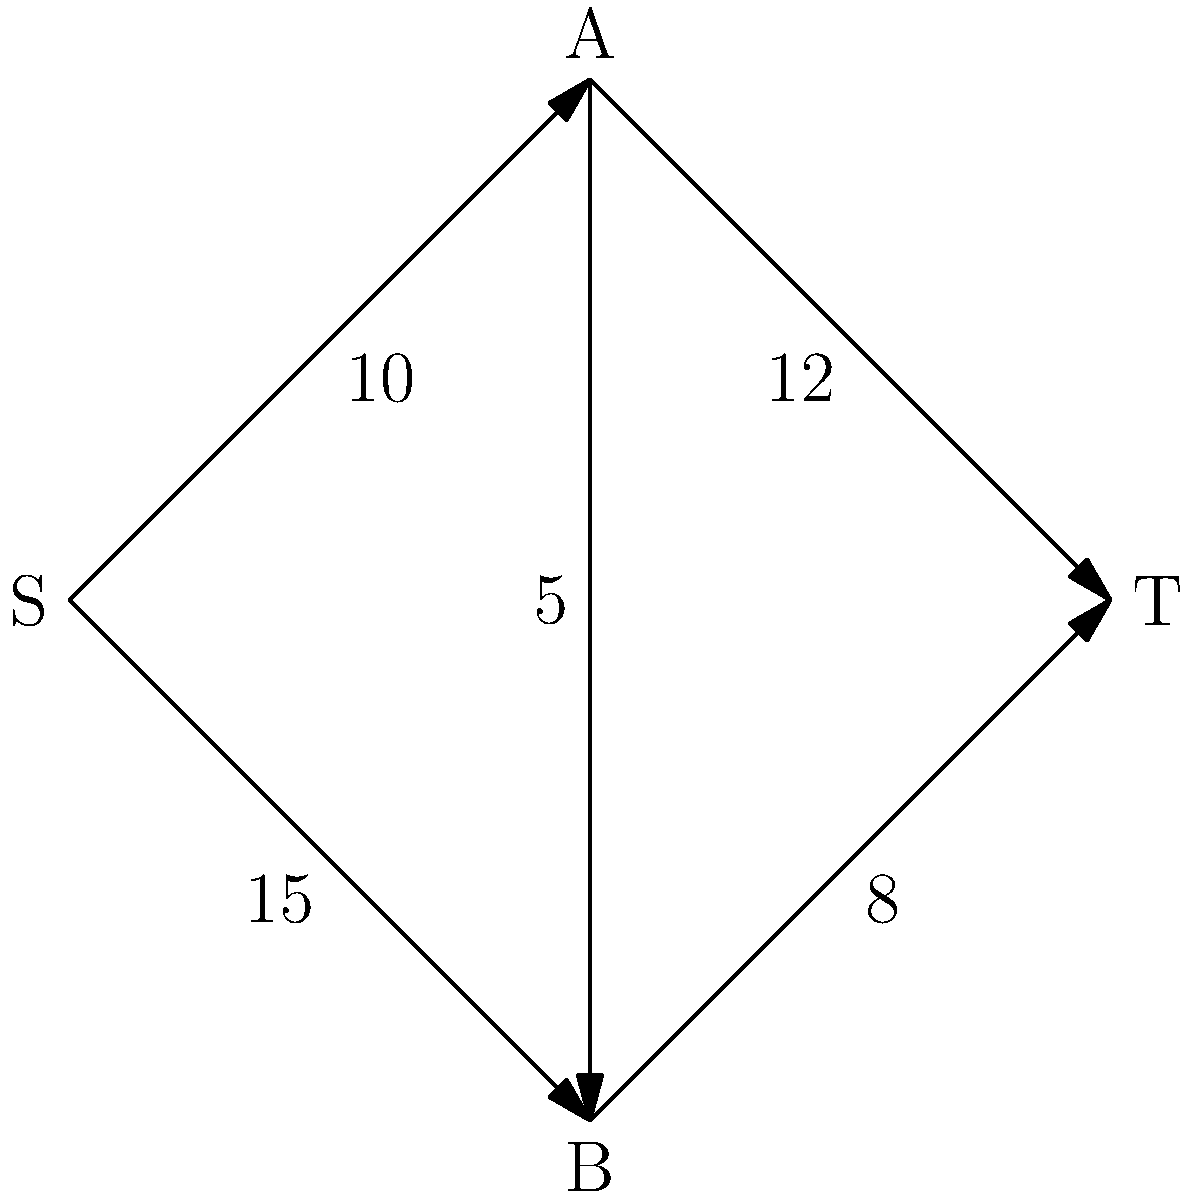You need to restock your vinyl records from two suppliers (A and B) to your thrift shop (T). The network flow diagram represents the distribution routes with their maximum capacities (in boxes of records). What is the maximum number of boxes of vinyl records you can receive at your shop in one shipment? To find the maximum flow from source S to sink T, we'll use the Ford-Fulkerson algorithm:

1. Identify possible paths from S to T:
   Path 1: S → A → T
   Path 2: S → B → T
   Path 3: S → A → B → T
   Path 4: S → B → A → T

2. Find the maximum flow for each path:
   Path 1: min(10, 12) = 10
   Path 2: min(15, 8) = 8
   Path 3: min(10, 5, 8) = 5
   Path 4: min(15, 5, 12) = 5

3. Start with Path 1:
   Flow = 10
   Remaining capacities: S→A: 0, A→T: 2

4. Add flow from Path 2:
   Flow = 10 + 8 = 18
   Remaining capacities: S→B: 7, B→T: 0

5. Add flow from Path 3:
   Not possible as S→A is saturated

6. Add flow from Path 4:
   Flow = 18 + 5 = 23
   Remaining capacities: S→B: 2, B→A: 0, A→T: 0

7. No more augmenting paths available

Therefore, the maximum flow from S to T is 23 boxes of vinyl records.
Answer: 23 boxes 